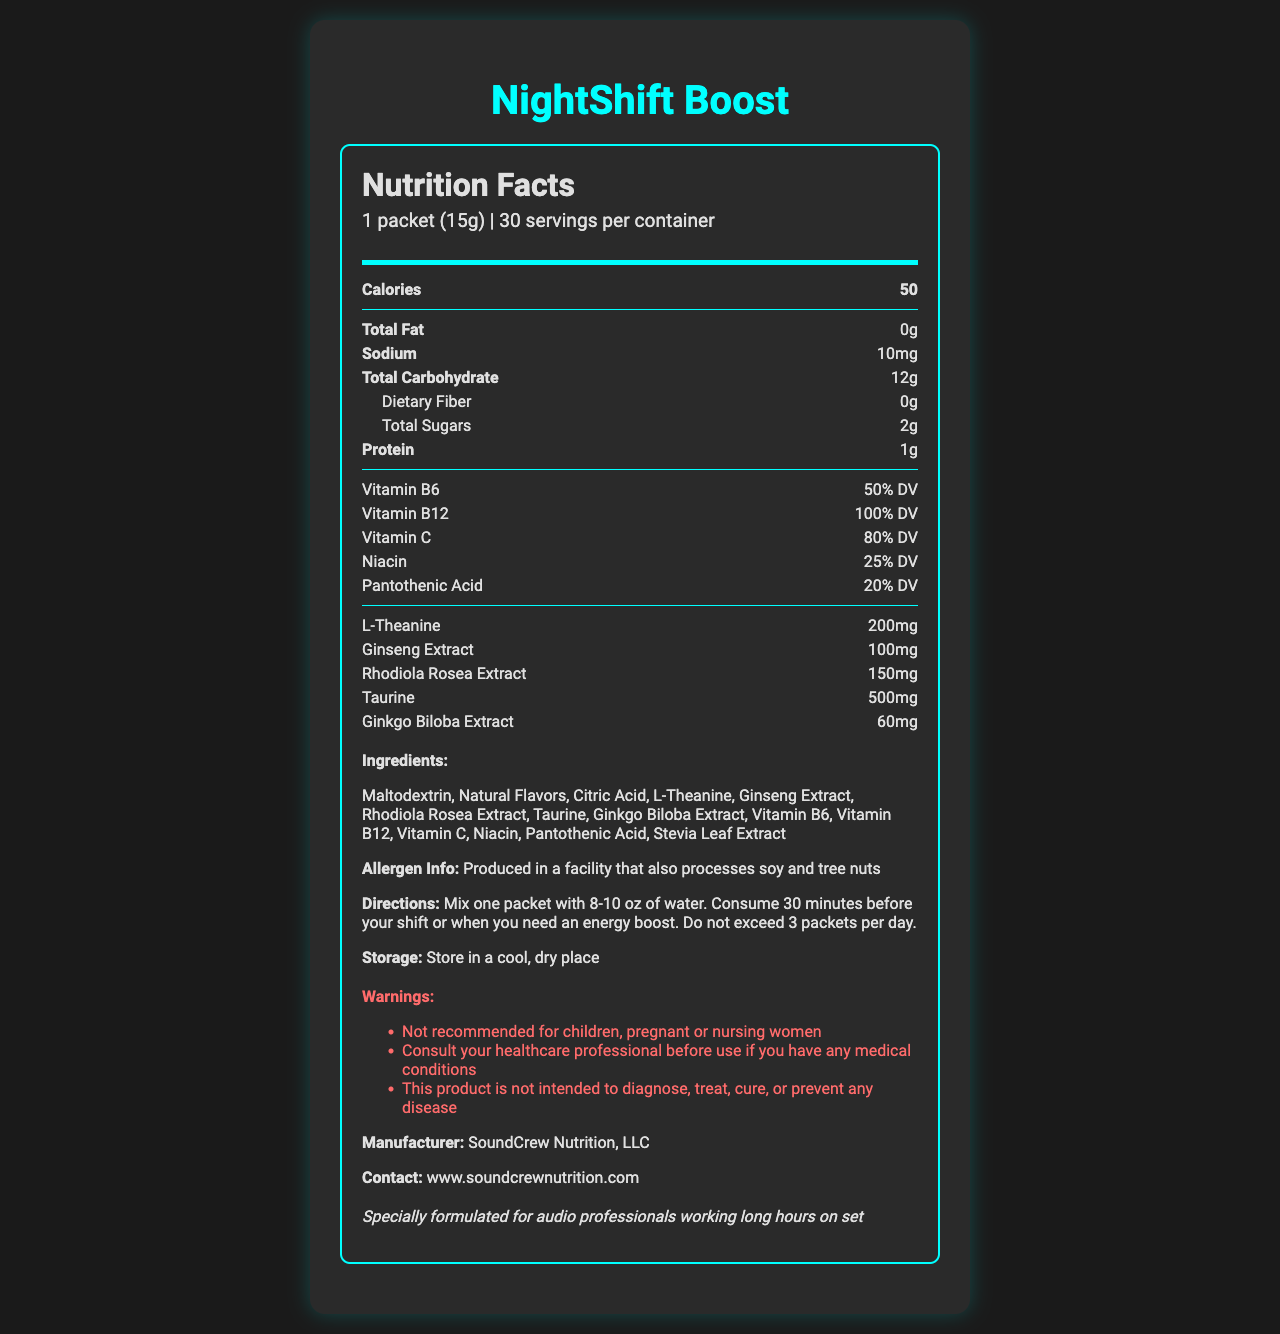who is the manufacturer of NightShift Boost? The document lists the manufacturer as SoundCrew Nutrition, LLC.
Answer: SoundCrew Nutrition, LLC how many servings are in one container of NightShift Boost? The document specifies that there are 30 servings per container.
Answer: 30 servings what is the serving size of NightShift Boost? The document states the serving size is 1 packet (15g).
Answer: 1 packet (15g) how many calories are in one serving of NightShift Boost? The document lists the calorie content as 50 per serving.
Answer: 50 calories how much protein is in one serving of NightShift Boost? The document mentions that there is 1g of protein per serving.
Answer: 1g of protein what is the daily value percentage of Vitamin B12 in one serving? The document shows that one serving of NightShift Boost contains 100% of the daily value of Vitamin B12.
Answer: 100% DV how much l-theanine is in one serving of NightShift Boost? The document specifies that there are 200mg of L-Theanine per serving.
Answer: 200mg which of the following statements is true about NightShift Boost?
A. It contains caffeine.
B. It has 20% DV of Vitamin C.
C. It is produced in a facility that also processes soy and tree nuts.
D. It is recommended for children. The document states that NightShift Boost is produced in a facility that also processes soy and tree nuts.
Answer: C which ingredient is not listed in NightShift Boost?
A. Rhodiola Rosea Extract
B. Ginko Biloba Extract
C. Caffeine
D. Stevia Leaf Extract The document mentions that NightShift Boost is caffeine-free and does not list Caffeine among its ingredients.
Answer: C is NightShift Boost recommended for pregnant or nursing women? The document includes a warning that the product is not recommended for pregnant or nursing women.
Answer: No please summarize the nutritional benefits and risks mentioned in the document for NightShift Boost. The document contains detailed nutritional information, summarizing that NightShift Boost is formulated with essential vitamins and ingredients for energy and alertness, but also highlights potential risks related to allergens and usage advisories.
Answer: NightShift Boost provides various vitamins and nutrients with no fat or very little sodium and sugars. Suitable for maintaining alertness with ingredients like L-Theanine and Rhodiola Rosea Extract. Produced in a facility that processes soy and tree nuts, which poses risks for individuals with allergies. Not recommended for children, pregnant or nursing women, and consultation with a healthcare professional is advised if there are any medical conditions. how long before your shift should you consume NightShift Boost? The directions in the document recommend consuming NightShift Boost 30 minutes before your shift.
Answer: 30 minutes is NightShift Boost designed specifically for audio professionals? The document mentions that NightShift Boost is specially formulated for audio professionals working long hours on set.
Answer: Yes what is the cost per serving of NightShift Boost? The document does not provide any information regarding the cost of the product, so the cost per serving cannot be determined.
Answer: Not enough information what vitamins are included in NightShift Boost and their respective daily value percentages? The document lists the vitamins included and their daily value percentages.
Answer: Vitamin B6: 50% DV, Vitamin B12: 100% DV, Vitamin C: 80% DV, Niacin: 25% DV, Pantothenic Acid: 20% DV 